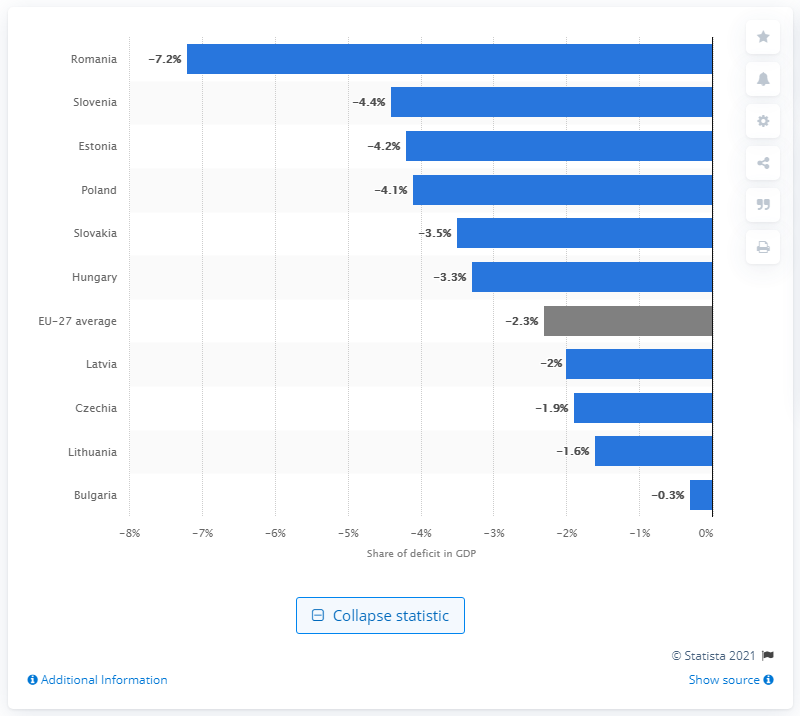Identify some key points in this picture. Bulgaria had the lowest deficit among all countries in the first quarter of 2020. 